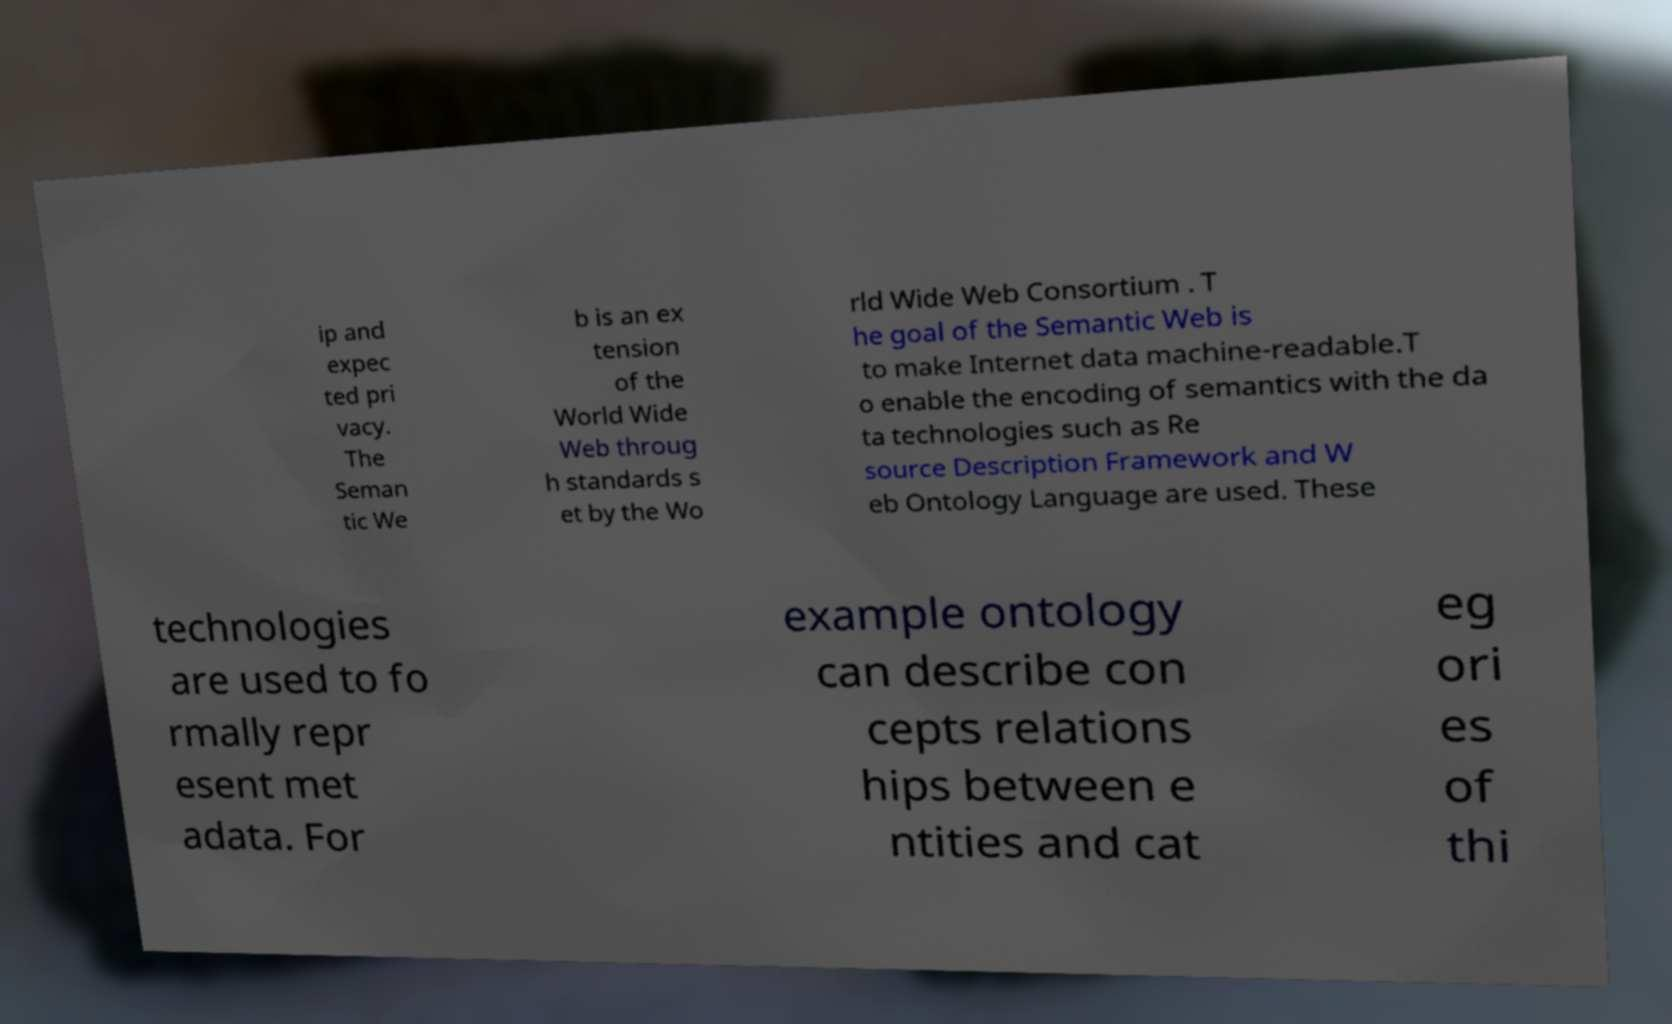Could you assist in decoding the text presented in this image and type it out clearly? ip and expec ted pri vacy. The Seman tic We b is an ex tension of the World Wide Web throug h standards s et by the Wo rld Wide Web Consortium . T he goal of the Semantic Web is to make Internet data machine-readable.T o enable the encoding of semantics with the da ta technologies such as Re source Description Framework and W eb Ontology Language are used. These technologies are used to fo rmally repr esent met adata. For example ontology can describe con cepts relations hips between e ntities and cat eg ori es of thi 